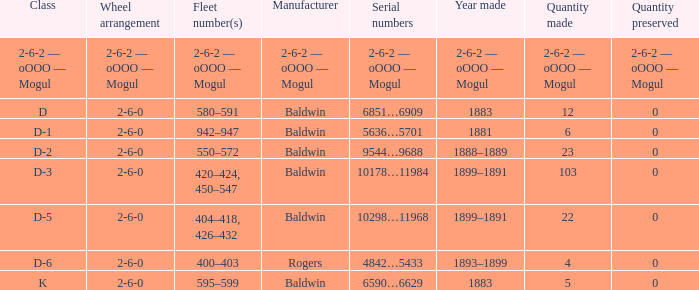What is the quantity made when the wheel arrangement is 2-6-0 and the class is k? 5.0. Parse the table in full. {'header': ['Class', 'Wheel arrangement', 'Fleet number(s)', 'Manufacturer', 'Serial numbers', 'Year made', 'Quantity made', 'Quantity preserved'], 'rows': [['2-6-2 — oOOO — Mogul', '2-6-2 — oOOO — Mogul', '2-6-2 — oOOO — Mogul', '2-6-2 — oOOO — Mogul', '2-6-2 — oOOO — Mogul', '2-6-2 — oOOO — Mogul', '2-6-2 — oOOO — Mogul', '2-6-2 — oOOO — Mogul'], ['D', '2-6-0', '580–591', 'Baldwin', '6851…6909', '1883', '12', '0'], ['D-1', '2-6-0', '942–947', 'Baldwin', '5636…5701', '1881', '6', '0'], ['D-2', '2-6-0', '550–572', 'Baldwin', '9544…9688', '1888–1889', '23', '0'], ['D-3', '2-6-0', '420–424, 450–547', 'Baldwin', '10178…11984', '1899–1891', '103', '0'], ['D-5', '2-6-0', '404–418, 426–432', 'Baldwin', '10298…11968', '1899–1891', '22', '0'], ['D-6', '2-6-0', '400–403', 'Rogers', '4842…5433', '1893–1899', '4', '0'], ['K', '2-6-0', '595–599', 'Baldwin', '6590…6629', '1883', '5', '0']]} 